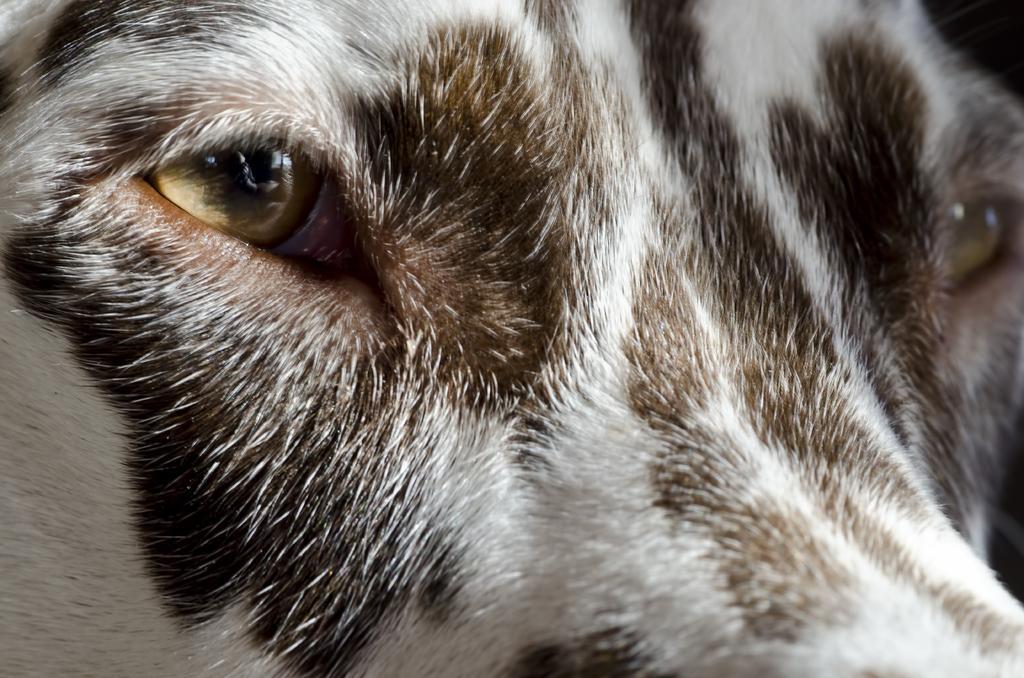Could you give a brief overview of what you see in this image? In the image we can see an animal. 